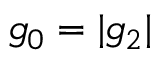<formula> <loc_0><loc_0><loc_500><loc_500>g _ { 0 } = | g _ { 2 } |</formula> 